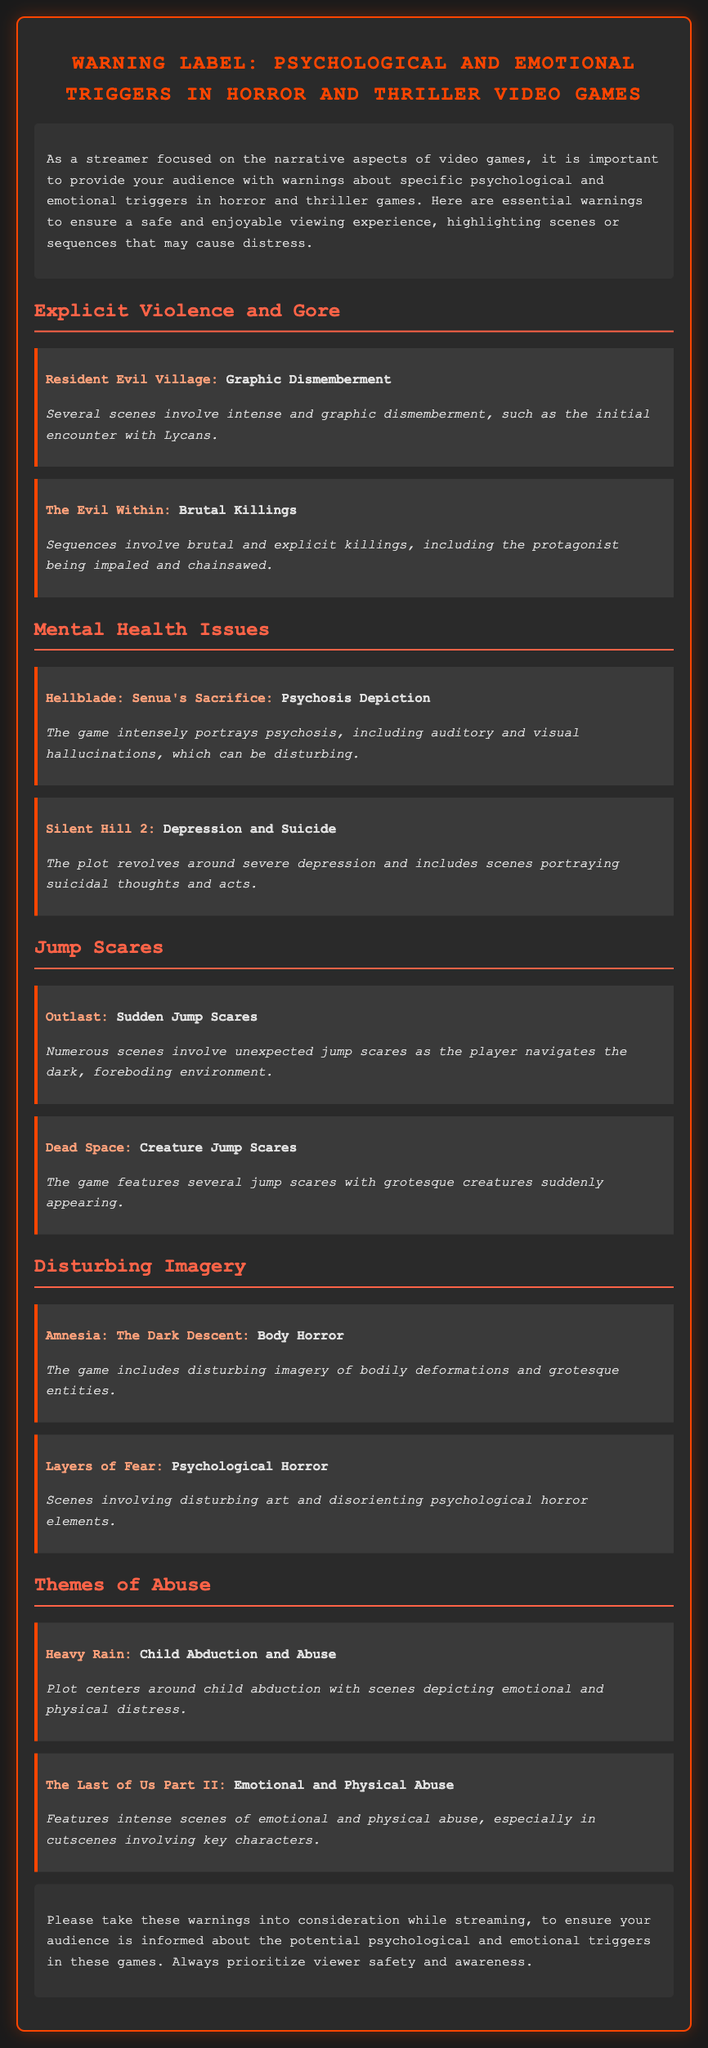What is the title of the document? The title of the document appears at the top of the rendered HTML and indicates the main topic being addressed.
Answer: Warning Label: Psychological and Emotional Triggers in Horror and Thriller Video Games Which game features graphic dismemberment? The section about explicit violence and gore lists the games and their respective trigger warnings, including one specific game noted for its graphic content.
Answer: Resident Evil Village What is a theme depicted in Silent Hill 2? The warning label for this game highlights specific themes that can cause distress, particularly concerning mental health issues.
Answer: Depression and Suicide How many jump scares are mentioned in Dead Space? The document indicates that this game features jump scares, but does not quantify them specifically; instead, it notes their presence generally.
Answer: Several What type of imagery is presented in Amnesia: The Dark Descent? The warning for this game specifically highlights certain characteristics of its disturbing visuals, categorizing the type of horror involved.
Answer: Body Horror What type of abuse is central to the plot of Heavy Rain? The document addresses abuse themes in several games, including its focus and specific aspects relevant to viewer sensitivity.
Answer: Child Abduction and Abuse Which game depicts psychosis? The mental health issues section provides examples of games that explore psychological themes, mentioning one notable title specifically.
Answer: Hellblade: Senua's Sacrifice 